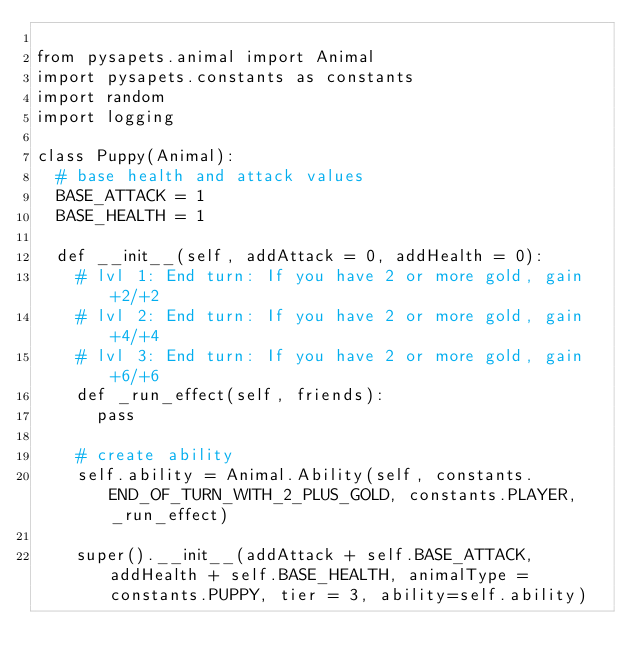Convert code to text. <code><loc_0><loc_0><loc_500><loc_500><_Python_>
from pysapets.animal import Animal
import pysapets.constants as constants
import random
import logging

class Puppy(Animal):
  # base health and attack values
  BASE_ATTACK = 1 
  BASE_HEALTH = 1 
  
  def __init__(self, addAttack = 0, addHealth = 0):
    # lvl 1: End turn: If you have 2 or more gold, gain +2/+2
    # lvl 2: End turn: If you have 2 or more gold, gain +4/+4
    # lvl 3: End turn: If you have 2 or more gold, gain +6/+6
    def _run_effect(self, friends):
      pass
    
    # create ability
    self.ability = Animal.Ability(self, constants.END_OF_TURN_WITH_2_PLUS_GOLD, constants.PLAYER, _run_effect)

    super().__init__(addAttack + self.BASE_ATTACK, addHealth + self.BASE_HEALTH, animalType = constants.PUPPY, tier = 3, ability=self.ability)

      </code> 